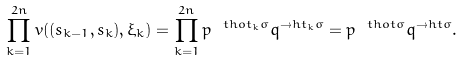Convert formula to latex. <formula><loc_0><loc_0><loc_500><loc_500>\prod _ { k = 1 } ^ { 2 n } v ( ( s _ { k - 1 } , s _ { k } ) , \xi _ { k } ) = \prod _ { k = 1 } ^ { 2 n } p ^ { \ t h o t _ { k } \sigma } q ^ { \to h t _ { k } \sigma } = p ^ { \ t h o t \sigma } q ^ { \to h t \sigma } .</formula> 